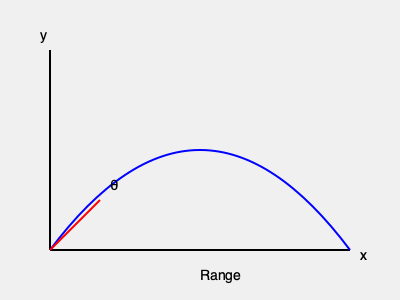As a experienced soccer player, you know the importance of understanding ball trajectory. If you kick a soccer ball with an initial velocity of 25 m/s at an angle of 30° above the horizontal, what is the maximum range (horizontal distance) the ball will travel, assuming no air resistance? (Use g = 9.8 m/s²) To solve this problem, we'll use the range equation for projectile motion:

1) The range equation is:
   $R = \frac{v_0^2 \sin(2\theta)}{g}$

   Where:
   $R$ = range
   $v_0$ = initial velocity
   $\theta$ = launch angle
   $g$ = acceleration due to gravity

2) We're given:
   $v_0 = 25$ m/s
   $\theta = 30°$
   $g = 9.8$ m/s²

3) Plugging these values into the equation:
   $R = \frac{(25\text{ m/s})^2 \sin(2(30°))}{9.8\text{ m/s}^2}$

4) Simplify:
   $R = \frac{625\text{ m}^2/\text{s}^2 \cdot \sin(60°)}{9.8\text{ m/s}^2}$

5) $\sin(60°) = \frac{\sqrt{3}}{2}$, so:
   $R = \frac{625\text{ m}^2/\text{s}^2 \cdot \frac{\sqrt{3}}{2}}{9.8\text{ m/s}^2}$

6) Calculate:
   $R \approx 55.1$ m

Therefore, the ball will travel approximately 55.1 meters horizontally.
Answer: 55.1 m 